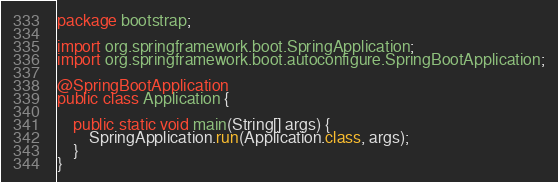Convert code to text. <code><loc_0><loc_0><loc_500><loc_500><_Java_>package bootstrap;

import org.springframework.boot.SpringApplication;
import org.springframework.boot.autoconfigure.SpringBootApplication;

@SpringBootApplication
public class Application {

    public static void main(String[] args) {
        SpringApplication.run(Application.class, args);
    }
}
</code> 